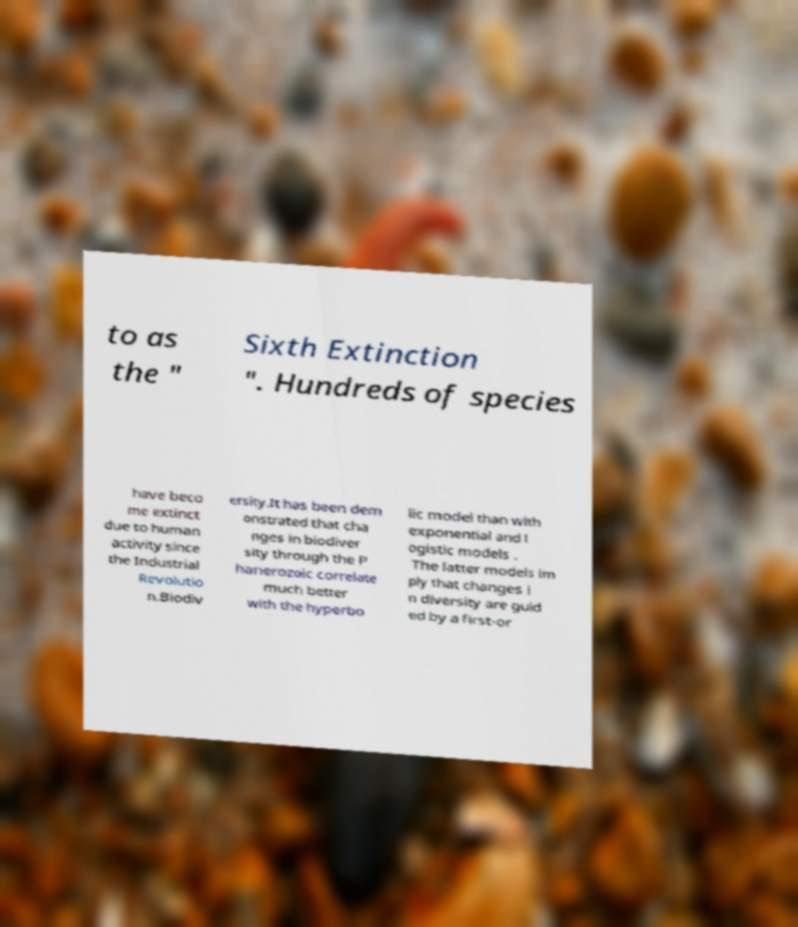I need the written content from this picture converted into text. Can you do that? to as the " Sixth Extinction ". Hundreds of species have beco me extinct due to human activity since the Industrial Revolutio n.Biodiv ersity.It has been dem onstrated that cha nges in biodiver sity through the P hanerozoic correlate much better with the hyperbo lic model than with exponential and l ogistic models . The latter models im ply that changes i n diversity are guid ed by a first-or 